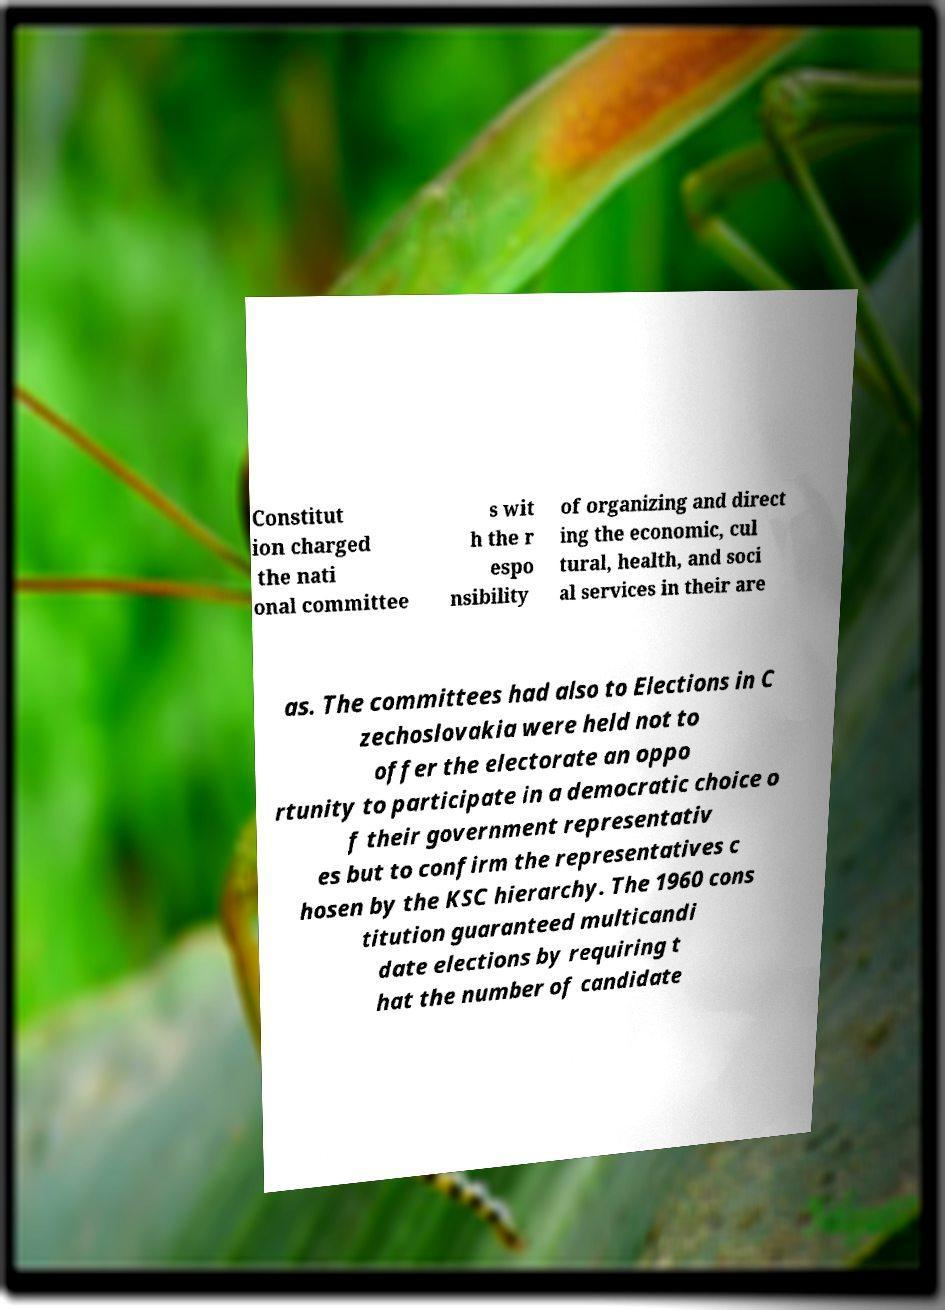What messages or text are displayed in this image? I need them in a readable, typed format. Constitut ion charged the nati onal committee s wit h the r espo nsibility of organizing and direct ing the economic, cul tural, health, and soci al services in their are as. The committees had also to Elections in C zechoslovakia were held not to offer the electorate an oppo rtunity to participate in a democratic choice o f their government representativ es but to confirm the representatives c hosen by the KSC hierarchy. The 1960 cons titution guaranteed multicandi date elections by requiring t hat the number of candidate 